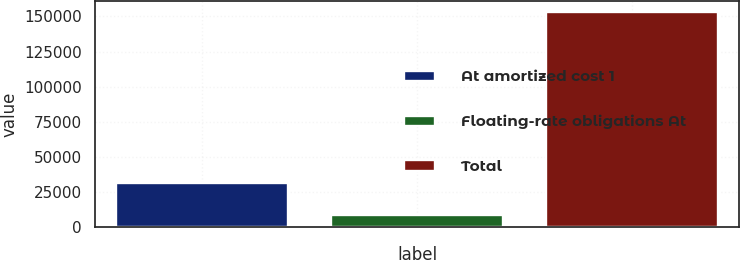Convert chart to OTSL. <chart><loc_0><loc_0><loc_500><loc_500><bar_chart><fcel>At amortized cost 1<fcel>Floating-rate obligations At<fcel>Total<nl><fcel>31741<fcel>8671<fcel>153513<nl></chart> 